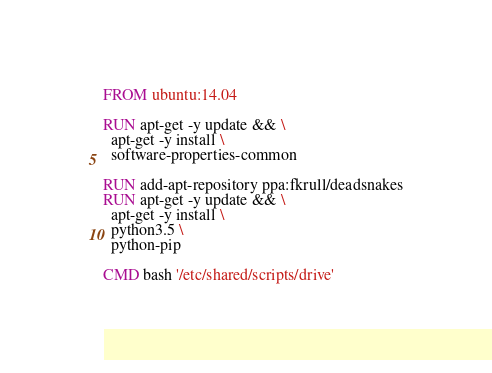Convert code to text. <code><loc_0><loc_0><loc_500><loc_500><_Dockerfile_>FROM ubuntu:14.04

RUN apt-get -y update && \
  apt-get -y install \
  software-properties-common

RUN add-apt-repository ppa:fkrull/deadsnakes
RUN apt-get -y update && \
  apt-get -y install \
  python3.5 \
  python-pip

CMD bash '/etc/shared/scripts/drive'
</code> 